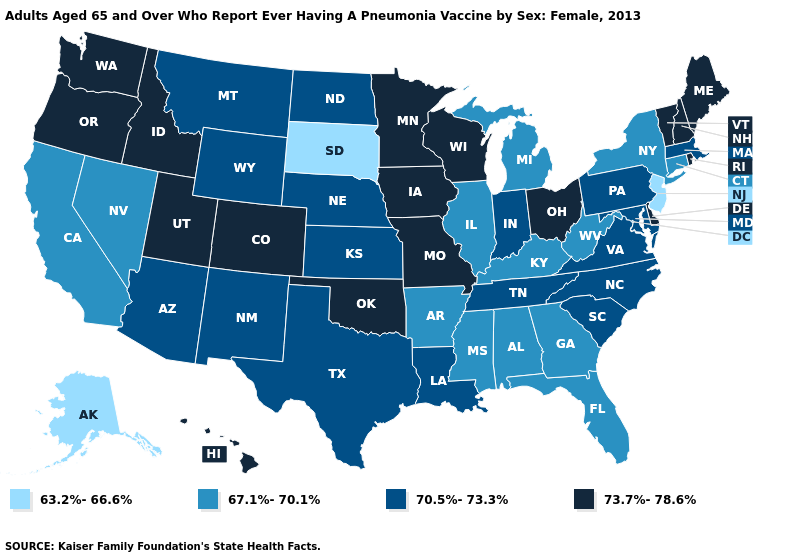What is the lowest value in the USA?
Write a very short answer. 63.2%-66.6%. Which states have the lowest value in the USA?
Short answer required. Alaska, New Jersey, South Dakota. Does Ohio have the highest value in the USA?
Give a very brief answer. Yes. What is the value of Georgia?
Concise answer only. 67.1%-70.1%. Name the states that have a value in the range 63.2%-66.6%?
Write a very short answer. Alaska, New Jersey, South Dakota. Among the states that border Connecticut , which have the lowest value?
Answer briefly. New York. Which states have the lowest value in the Northeast?
Give a very brief answer. New Jersey. Which states have the lowest value in the USA?
Short answer required. Alaska, New Jersey, South Dakota. Among the states that border Illinois , does Iowa have the highest value?
Give a very brief answer. Yes. Among the states that border Kansas , does Colorado have the lowest value?
Answer briefly. No. Which states have the lowest value in the USA?
Keep it brief. Alaska, New Jersey, South Dakota. Which states have the highest value in the USA?
Be succinct. Colorado, Delaware, Hawaii, Idaho, Iowa, Maine, Minnesota, Missouri, New Hampshire, Ohio, Oklahoma, Oregon, Rhode Island, Utah, Vermont, Washington, Wisconsin. Which states hav the highest value in the West?
Quick response, please. Colorado, Hawaii, Idaho, Oregon, Utah, Washington. What is the value of Minnesota?
Quick response, please. 73.7%-78.6%. 